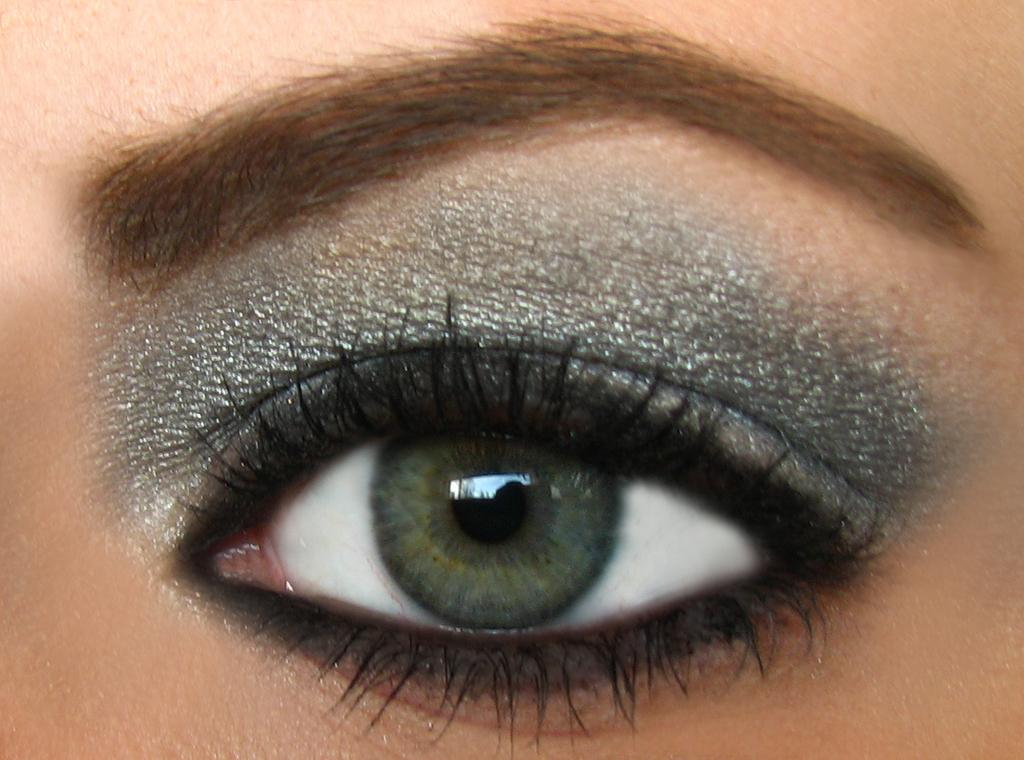What is the main subject of the image? The main subject of the image is the eye of a person. Can you describe the eye in the image? The eye appears to be a close-up view, showing details such as the iris and eyelashes. What size is the mailbox next to the eye in the image? There is no mailbox present in the image; it only features the eye of a person. What type of bottle is being held by the eye in the image? There is no bottle present in the image; it only features the eye of a person. 